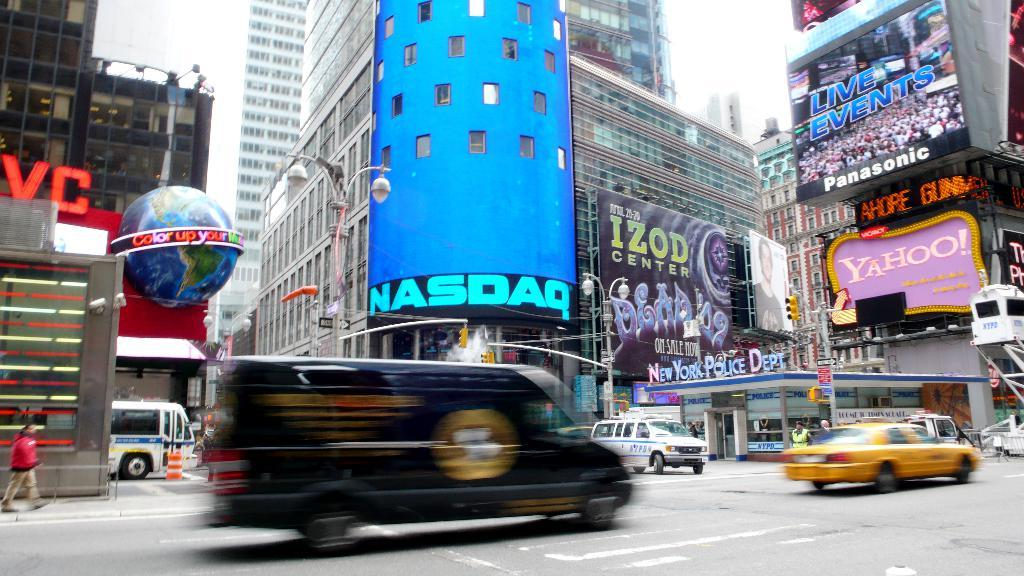<image>
Offer a succinct explanation of the picture presented. A city scene on which an advert for NASDAQ is visible. 